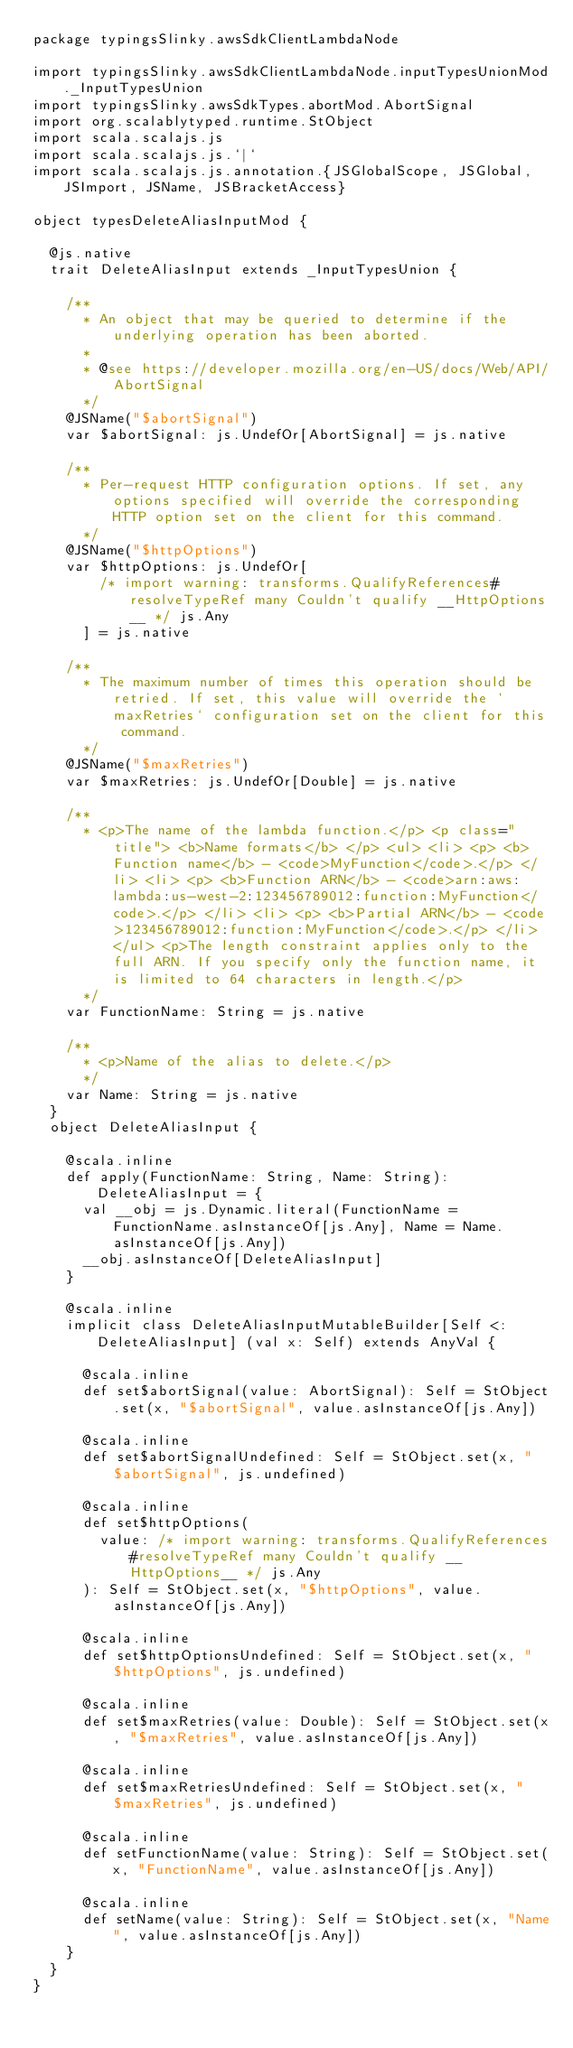Convert code to text. <code><loc_0><loc_0><loc_500><loc_500><_Scala_>package typingsSlinky.awsSdkClientLambdaNode

import typingsSlinky.awsSdkClientLambdaNode.inputTypesUnionMod._InputTypesUnion
import typingsSlinky.awsSdkTypes.abortMod.AbortSignal
import org.scalablytyped.runtime.StObject
import scala.scalajs.js
import scala.scalajs.js.`|`
import scala.scalajs.js.annotation.{JSGlobalScope, JSGlobal, JSImport, JSName, JSBracketAccess}

object typesDeleteAliasInputMod {
  
  @js.native
  trait DeleteAliasInput extends _InputTypesUnion {
    
    /**
      * An object that may be queried to determine if the underlying operation has been aborted.
      *
      * @see https://developer.mozilla.org/en-US/docs/Web/API/AbortSignal
      */
    @JSName("$abortSignal")
    var $abortSignal: js.UndefOr[AbortSignal] = js.native
    
    /**
      * Per-request HTTP configuration options. If set, any options specified will override the corresponding HTTP option set on the client for this command.
      */
    @JSName("$httpOptions")
    var $httpOptions: js.UndefOr[
        /* import warning: transforms.QualifyReferences#resolveTypeRef many Couldn't qualify __HttpOptions__ */ js.Any
      ] = js.native
    
    /**
      * The maximum number of times this operation should be retried. If set, this value will override the `maxRetries` configuration set on the client for this command.
      */
    @JSName("$maxRetries")
    var $maxRetries: js.UndefOr[Double] = js.native
    
    /**
      * <p>The name of the lambda function.</p> <p class="title"> <b>Name formats</b> </p> <ul> <li> <p> <b>Function name</b> - <code>MyFunction</code>.</p> </li> <li> <p> <b>Function ARN</b> - <code>arn:aws:lambda:us-west-2:123456789012:function:MyFunction</code>.</p> </li> <li> <p> <b>Partial ARN</b> - <code>123456789012:function:MyFunction</code>.</p> </li> </ul> <p>The length constraint applies only to the full ARN. If you specify only the function name, it is limited to 64 characters in length.</p>
      */
    var FunctionName: String = js.native
    
    /**
      * <p>Name of the alias to delete.</p>
      */
    var Name: String = js.native
  }
  object DeleteAliasInput {
    
    @scala.inline
    def apply(FunctionName: String, Name: String): DeleteAliasInput = {
      val __obj = js.Dynamic.literal(FunctionName = FunctionName.asInstanceOf[js.Any], Name = Name.asInstanceOf[js.Any])
      __obj.asInstanceOf[DeleteAliasInput]
    }
    
    @scala.inline
    implicit class DeleteAliasInputMutableBuilder[Self <: DeleteAliasInput] (val x: Self) extends AnyVal {
      
      @scala.inline
      def set$abortSignal(value: AbortSignal): Self = StObject.set(x, "$abortSignal", value.asInstanceOf[js.Any])
      
      @scala.inline
      def set$abortSignalUndefined: Self = StObject.set(x, "$abortSignal", js.undefined)
      
      @scala.inline
      def set$httpOptions(
        value: /* import warning: transforms.QualifyReferences#resolveTypeRef many Couldn't qualify __HttpOptions__ */ js.Any
      ): Self = StObject.set(x, "$httpOptions", value.asInstanceOf[js.Any])
      
      @scala.inline
      def set$httpOptionsUndefined: Self = StObject.set(x, "$httpOptions", js.undefined)
      
      @scala.inline
      def set$maxRetries(value: Double): Self = StObject.set(x, "$maxRetries", value.asInstanceOf[js.Any])
      
      @scala.inline
      def set$maxRetriesUndefined: Self = StObject.set(x, "$maxRetries", js.undefined)
      
      @scala.inline
      def setFunctionName(value: String): Self = StObject.set(x, "FunctionName", value.asInstanceOf[js.Any])
      
      @scala.inline
      def setName(value: String): Self = StObject.set(x, "Name", value.asInstanceOf[js.Any])
    }
  }
}
</code> 